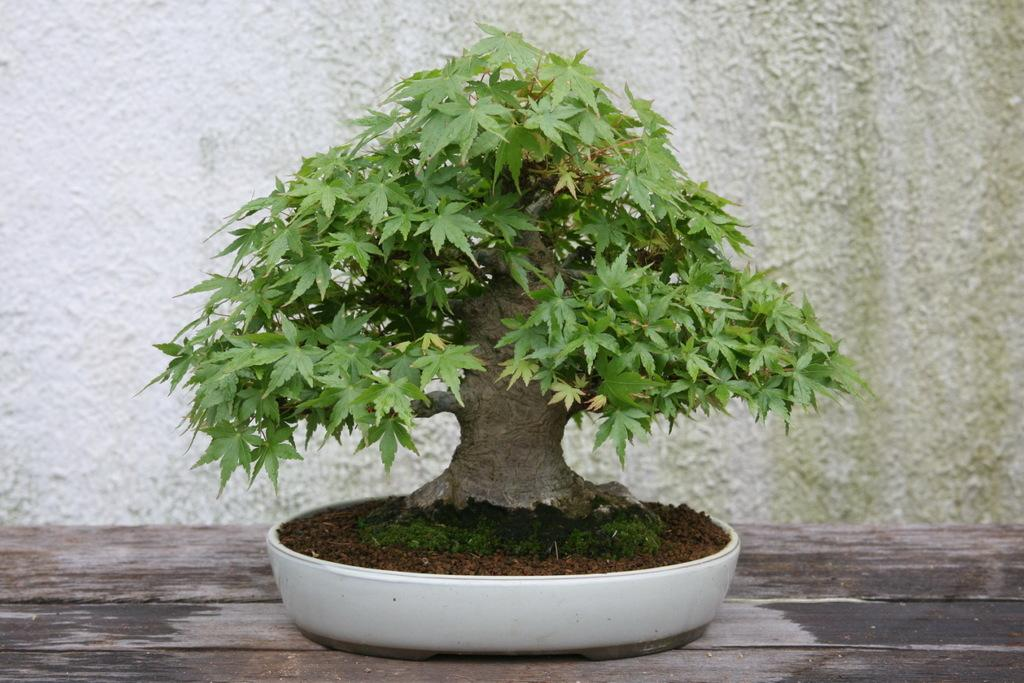What type of living organism is in the image? There is a plant in the image. What color is the pot that the plant is in? The plant is in a white-colored pot. What can be seen at the base of the plant? There is soil visible in the image. What type of surface is the plant resting on? The plant is on a wooden surface. What is visible in the background of the image? There is a wall in the background of the image. What type of gold bottle can be seen next to the plant in the image? There is no gold bottle present in the image. Is there any corn growing alongside the plant in the image? There is no corn visible in the image; it only features a plant in a pot. 